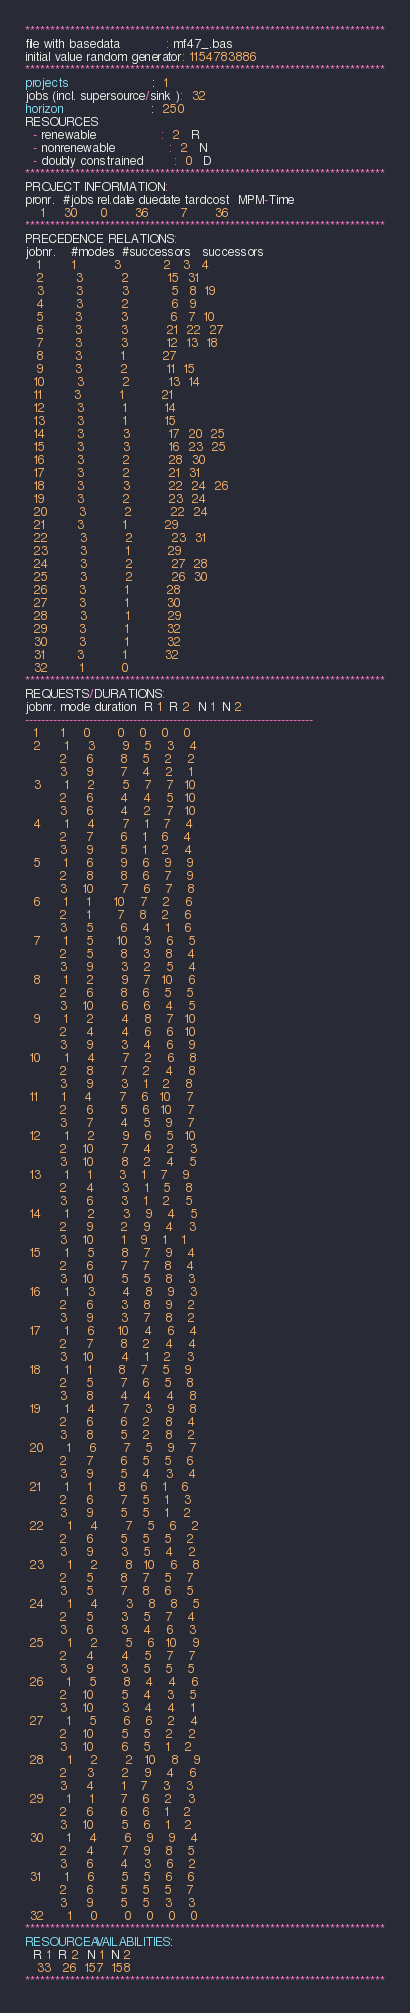<code> <loc_0><loc_0><loc_500><loc_500><_ObjectiveC_>************************************************************************
file with basedata            : mf47_.bas
initial value random generator: 1154783886
************************************************************************
projects                      :  1
jobs (incl. supersource/sink ):  32
horizon                       :  250
RESOURCES
  - renewable                 :  2   R
  - nonrenewable              :  2   N
  - doubly constrained        :  0   D
************************************************************************
PROJECT INFORMATION:
pronr.  #jobs rel.date duedate tardcost  MPM-Time
    1     30      0       36        7       36
************************************************************************
PRECEDENCE RELATIONS:
jobnr.    #modes  #successors   successors
   1        1          3           2   3   4
   2        3          2          15  31
   3        3          3           5   8  19
   4        3          2           6   9
   5        3          3           6   7  10
   6        3          3          21  22  27
   7        3          3          12  13  18
   8        3          1          27
   9        3          2          11  15
  10        3          2          13  14
  11        3          1          21
  12        3          1          14
  13        3          1          15
  14        3          3          17  20  25
  15        3          3          16  23  25
  16        3          2          28  30
  17        3          2          21  31
  18        3          3          22  24  26
  19        3          2          23  24
  20        3          2          22  24
  21        3          1          29
  22        3          2          23  31
  23        3          1          29
  24        3          2          27  28
  25        3          2          26  30
  26        3          1          28
  27        3          1          30
  28        3          1          29
  29        3          1          32
  30        3          1          32
  31        3          1          32
  32        1          0        
************************************************************************
REQUESTS/DURATIONS:
jobnr. mode duration  R 1  R 2  N 1  N 2
------------------------------------------------------------------------
  1      1     0       0    0    0    0
  2      1     3       9    5    3    4
         2     6       8    5    2    2
         3     9       7    4    2    1
  3      1     2       5    7    7   10
         2     6       4    4    5   10
         3     6       4    2    7   10
  4      1     4       7    1    7    4
         2     7       6    1    6    4
         3     9       5    1    2    4
  5      1     6       9    6    9    9
         2     8       8    6    7    9
         3    10       7    6    7    8
  6      1     1      10    7    2    6
         2     1       7    8    2    6
         3     5       6    4    1    6
  7      1     5      10    3    6    5
         2     5       8    3    8    4
         3     9       3    2    5    4
  8      1     2       9    7   10    6
         2     6       8    6    5    5
         3    10       6    6    4    5
  9      1     2       4    8    7   10
         2     4       4    6    6   10
         3     9       3    4    6    9
 10      1     4       7    2    6    8
         2     8       7    2    4    8
         3     9       3    1    2    8
 11      1     4       7    6   10    7
         2     6       5    6   10    7
         3     7       4    5    9    7
 12      1     2       9    6    5   10
         2    10       7    4    2    3
         3    10       8    2    4    5
 13      1     1       3    1    7    9
         2     4       3    1    5    8
         3     6       3    1    2    5
 14      1     2       3    9    4    5
         2     9       2    9    4    3
         3    10       1    9    1    1
 15      1     5       8    7    9    4
         2     6       7    7    8    4
         3    10       5    5    8    3
 16      1     3       4    8    9    3
         2     6       3    8    9    2
         3     9       3    7    8    2
 17      1     6      10    4    6    4
         2     7       8    2    4    4
         3    10       4    1    2    3
 18      1     1       8    7    5    9
         2     5       7    6    5    8
         3     8       4    4    4    8
 19      1     4       7    3    9    8
         2     6       6    2    8    4
         3     8       5    2    8    2
 20      1     6       7    5    9    7
         2     7       6    5    5    6
         3     9       5    4    3    4
 21      1     1       8    6    1    6
         2     6       7    5    1    3
         3     9       5    5    1    2
 22      1     4       7    5    6    2
         2     6       5    5    5    2
         3     9       3    5    4    2
 23      1     2       8   10    6    8
         2     5       8    7    5    7
         3     5       7    8    6    5
 24      1     4       3    8    8    5
         2     5       3    5    7    4
         3     6       3    4    6    3
 25      1     2       5    6   10    9
         2     4       4    5    7    7
         3     9       3    5    5    5
 26      1     5       8    4    4    6
         2    10       5    4    3    5
         3    10       3    4    4    1
 27      1     5       6    6    2    4
         2    10       5    5    2    2
         3    10       6    5    1    2
 28      1     2       2   10    8    9
         2     3       2    9    4    6
         3     4       1    7    3    3
 29      1     1       7    6    2    3
         2     6       6    6    1    2
         3    10       5    6    1    2
 30      1     4       6    9    9    4
         2     4       7    9    8    5
         3     6       4    3    6    2
 31      1     6       5    5    6    6
         2     6       5    5    5    7
         3     9       5    5    3    3
 32      1     0       0    0    0    0
************************************************************************
RESOURCEAVAILABILITIES:
  R 1  R 2  N 1  N 2
   33   26  157  158
************************************************************************
</code> 